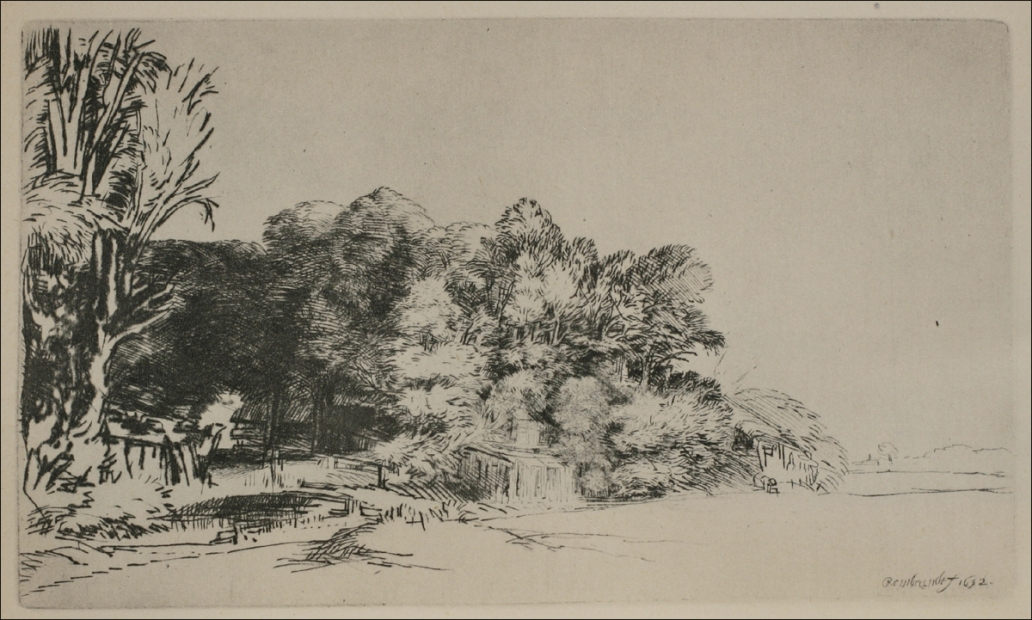What mood does this image evoke, and how does the artist convey it? The image evokes a mood of serenity and bucolic calm, likely intended to transport the viewer to a simpler time of pastoral beauty. The artist conveys this mood through the use of gentle etching lines that create a harmonious interplay of light and shadow. The composition's depth, with foreground details leading into quieter background elements, also contributes to a sense of peaceful seclusion. The balance between detailed areas and more spacious sections of the etching allows the viewer's gaze to rest and explore without feeling overwhelmed, enhancing the overall tranquil effect. 